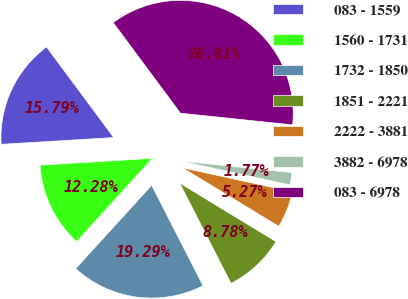Convert chart to OTSL. <chart><loc_0><loc_0><loc_500><loc_500><pie_chart><fcel>083 - 1559<fcel>1560 - 1731<fcel>1732 - 1850<fcel>1851 - 2221<fcel>2222 - 3881<fcel>3882 - 6978<fcel>083 - 6978<nl><fcel>15.79%<fcel>12.28%<fcel>19.29%<fcel>8.78%<fcel>5.27%<fcel>1.77%<fcel>36.81%<nl></chart> 